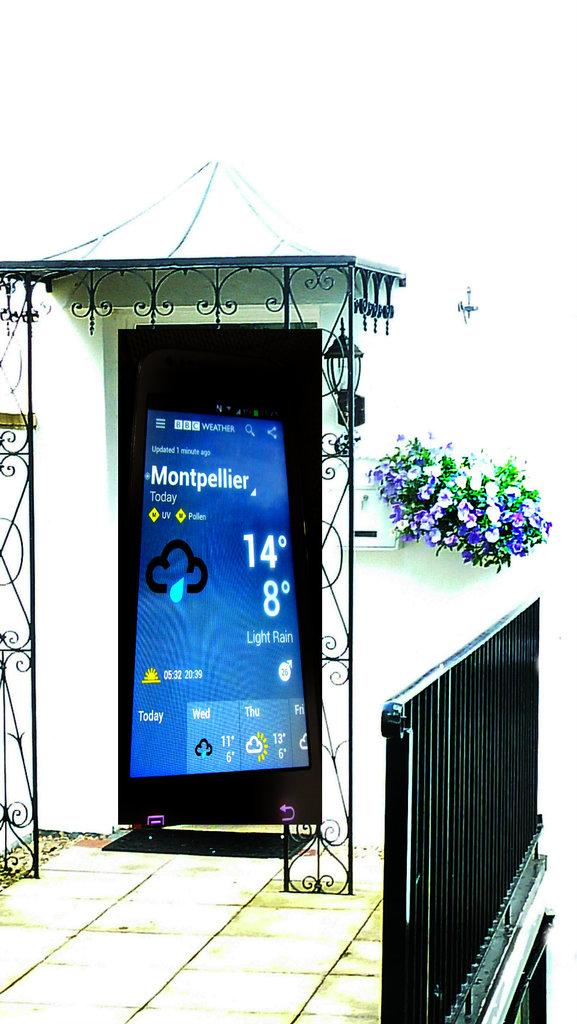<image>
Relay a brief, clear account of the picture shown. The screen of a cell phone indicates that it was updated one minute ago. 